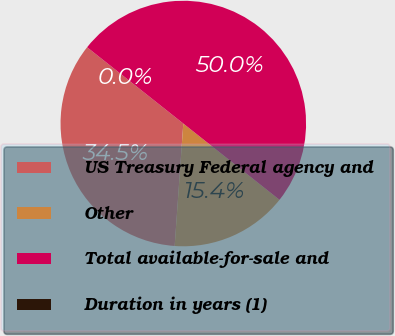<chart> <loc_0><loc_0><loc_500><loc_500><pie_chart><fcel>US Treasury Federal agency and<fcel>Other<fcel>Total available-for-sale and<fcel>Duration in years (1)<nl><fcel>34.55%<fcel>15.45%<fcel>50.0%<fcel>0.0%<nl></chart> 